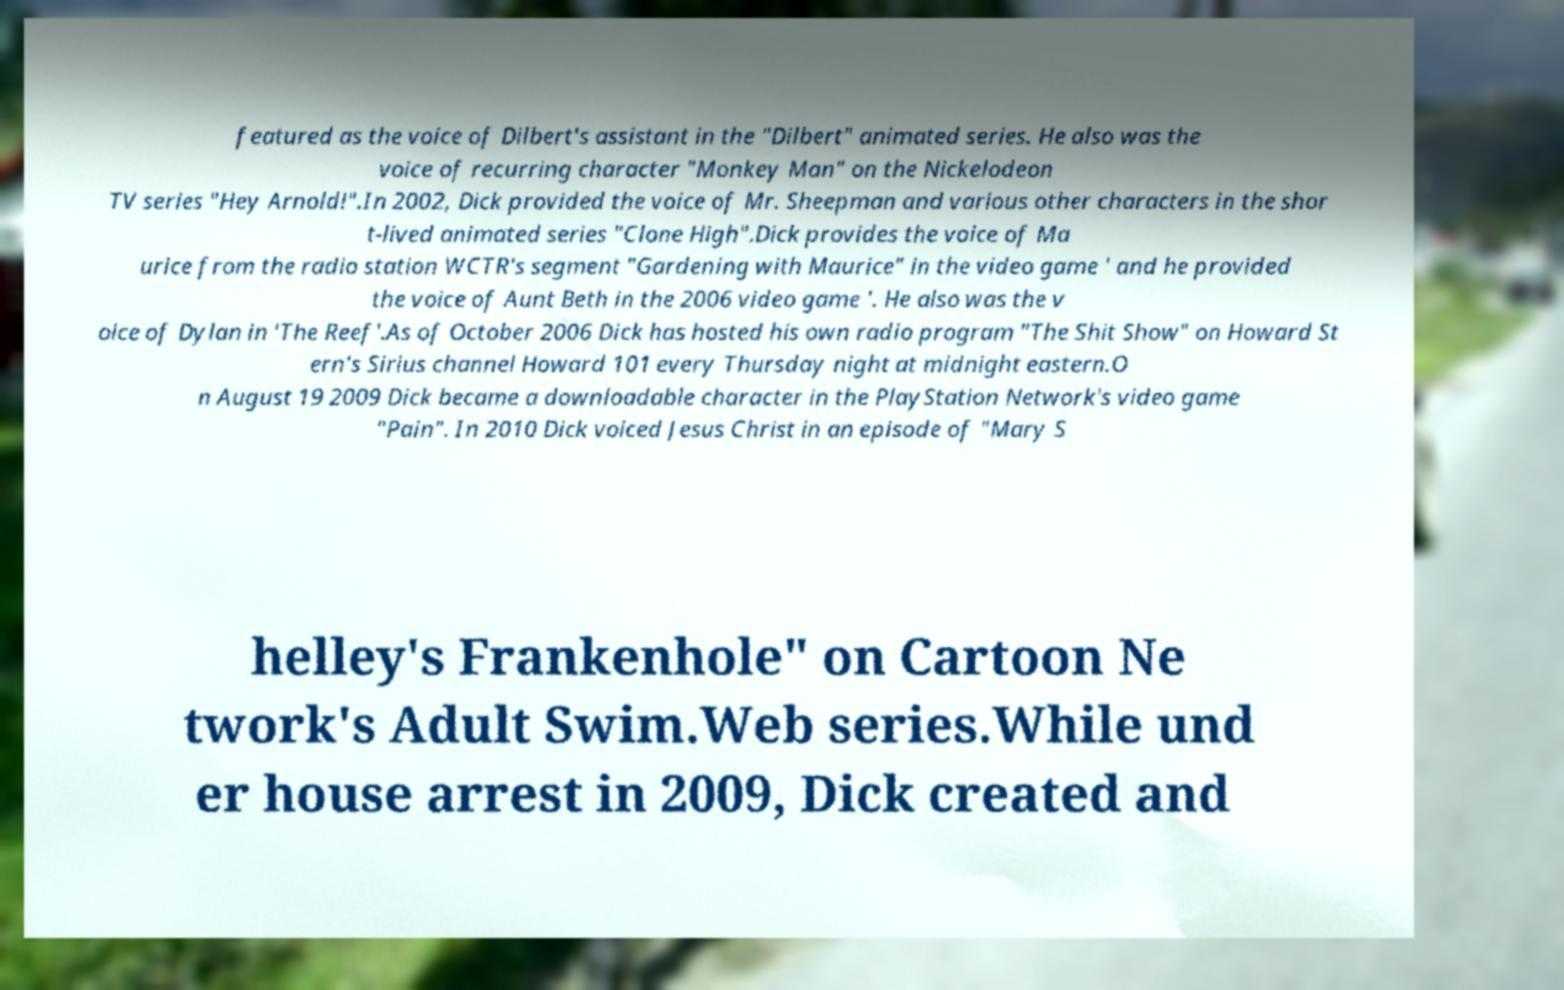Could you assist in decoding the text presented in this image and type it out clearly? featured as the voice of Dilbert's assistant in the "Dilbert" animated series. He also was the voice of recurring character "Monkey Man" on the Nickelodeon TV series "Hey Arnold!".In 2002, Dick provided the voice of Mr. Sheepman and various other characters in the shor t-lived animated series "Clone High".Dick provides the voice of Ma urice from the radio station WCTR's segment "Gardening with Maurice" in the video game ' and he provided the voice of Aunt Beth in the 2006 video game '. He also was the v oice of Dylan in 'The Reef'.As of October 2006 Dick has hosted his own radio program "The Shit Show" on Howard St ern's Sirius channel Howard 101 every Thursday night at midnight eastern.O n August 19 2009 Dick became a downloadable character in the PlayStation Network's video game "Pain". In 2010 Dick voiced Jesus Christ in an episode of "Mary S helley's Frankenhole" on Cartoon Ne twork's Adult Swim.Web series.While und er house arrest in 2009, Dick created and 